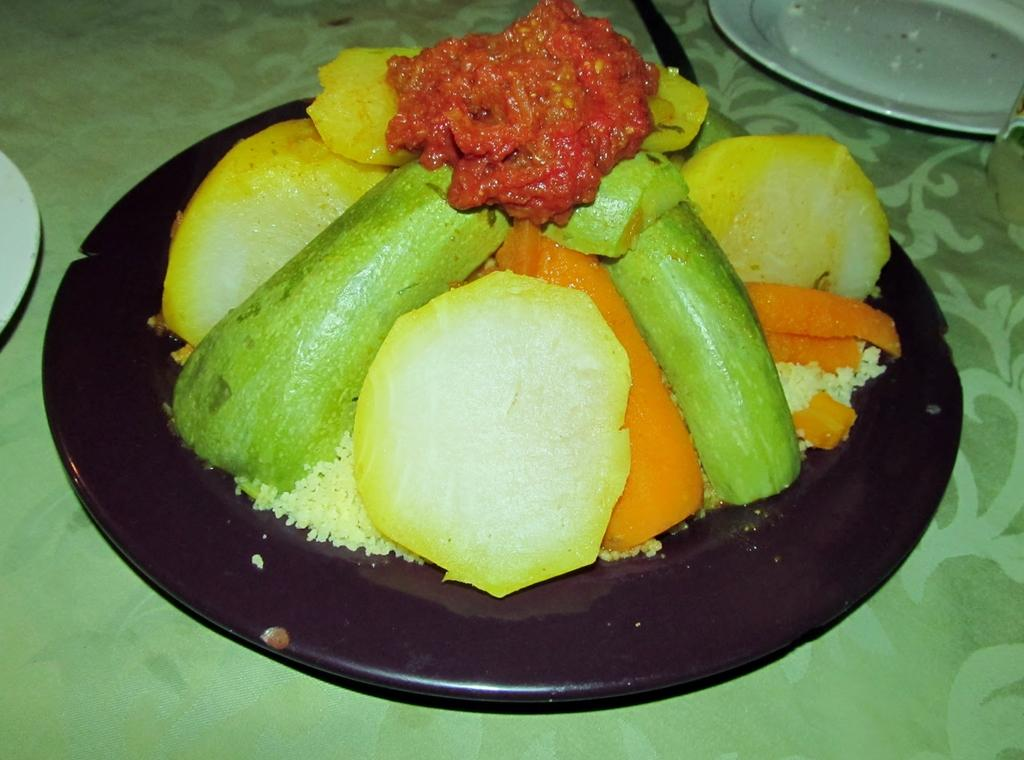What is on the plate that is visible in the image? There is a food item on a plate in the image. Where is the plate located in the image? The plate is placed on a table. Are there any other plates on the table? Yes, there are additional plates on the table. What type of cannon is present on the table in the image? There is no cannon present on the table in the image. 